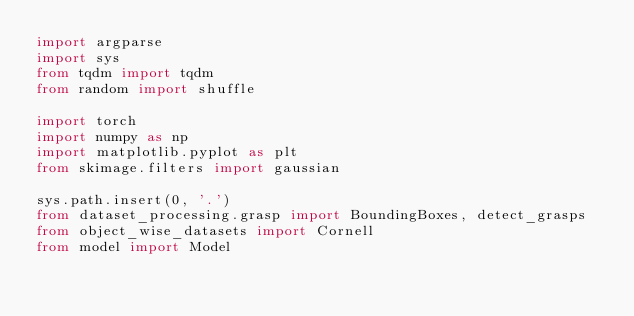<code> <loc_0><loc_0><loc_500><loc_500><_Python_>import argparse
import sys
from tqdm import tqdm
from random import shuffle

import torch
import numpy as np
import matplotlib.pyplot as plt
from skimage.filters import gaussian

sys.path.insert(0, '.')
from dataset_processing.grasp import BoundingBoxes, detect_grasps
from object_wise_datasets import Cornell
from model import Model


</code> 